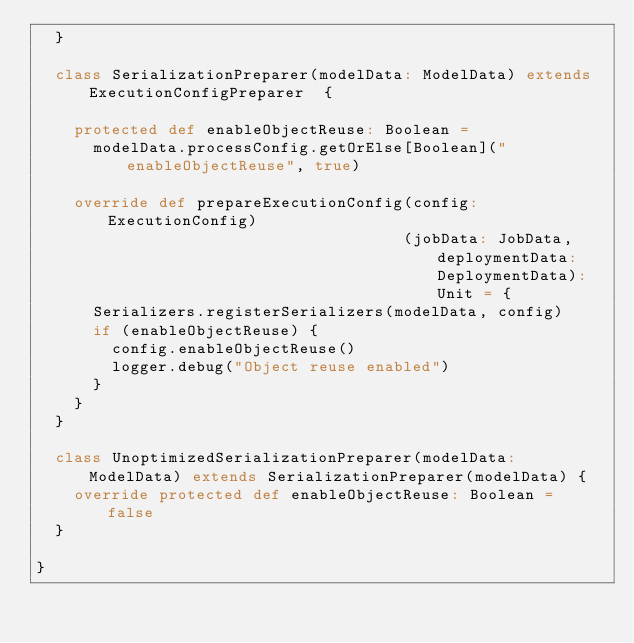<code> <loc_0><loc_0><loc_500><loc_500><_Scala_>  }

  class SerializationPreparer(modelData: ModelData) extends ExecutionConfigPreparer  {

    protected def enableObjectReuse: Boolean =
      modelData.processConfig.getOrElse[Boolean]("enableObjectReuse", true)

    override def prepareExecutionConfig(config: ExecutionConfig)
                                       (jobData: JobData, deploymentData: DeploymentData): Unit = {
      Serializers.registerSerializers(modelData, config)
      if (enableObjectReuse) {
        config.enableObjectReuse()
        logger.debug("Object reuse enabled")
      }
    }
  }

  class UnoptimizedSerializationPreparer(modelData: ModelData) extends SerializationPreparer(modelData) {
    override protected def enableObjectReuse: Boolean = false
  }

}
</code> 